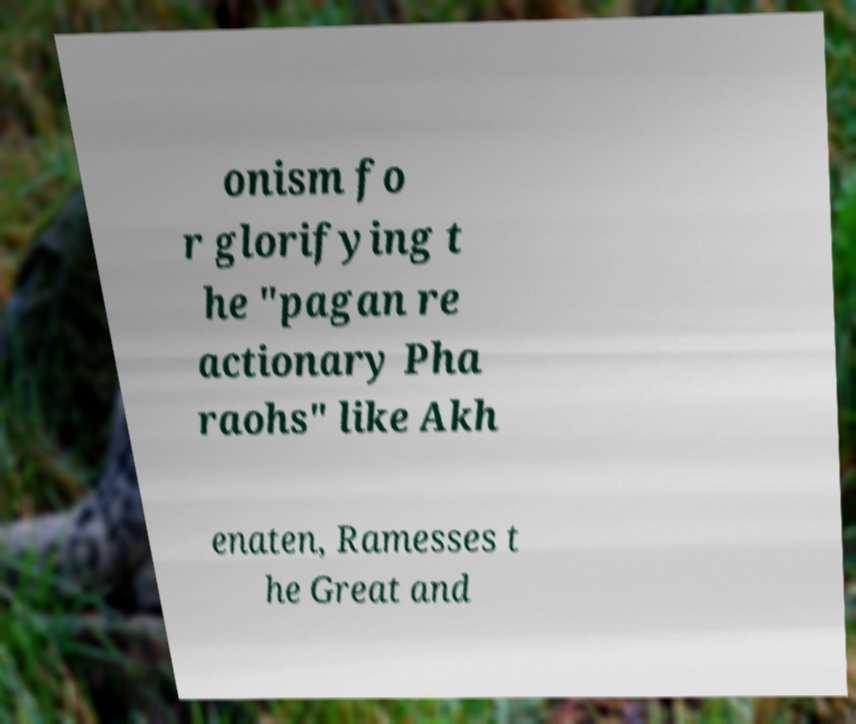Please read and relay the text visible in this image. What does it say? onism fo r glorifying t he "pagan re actionary Pha raohs" like Akh enaten, Ramesses t he Great and 